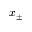<formula> <loc_0><loc_0><loc_500><loc_500>x _ { \pm }</formula> 